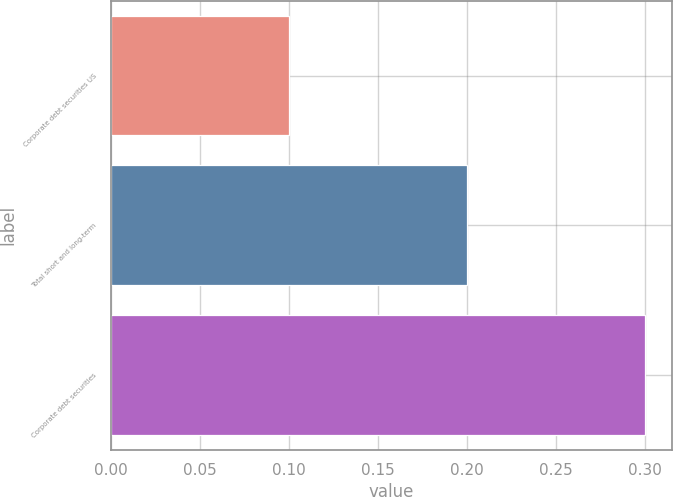<chart> <loc_0><loc_0><loc_500><loc_500><bar_chart><fcel>Corporate debt securities US<fcel>Total short and long-term<fcel>Corporate debt securities<nl><fcel>0.1<fcel>0.2<fcel>0.3<nl></chart> 